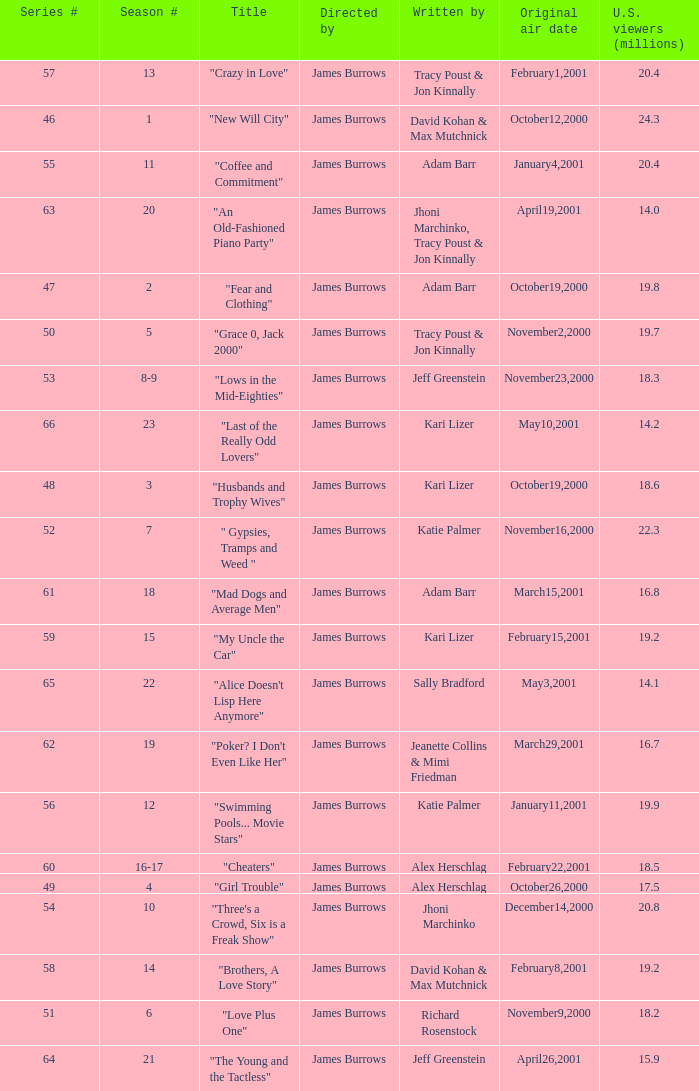Who wrote the episode titled "An Old-fashioned Piano Party"? Jhoni Marchinko, Tracy Poust & Jon Kinnally. 